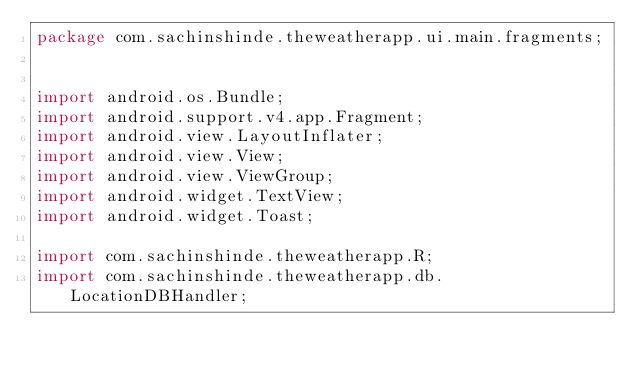<code> <loc_0><loc_0><loc_500><loc_500><_Java_>package com.sachinshinde.theweatherapp.ui.main.fragments;


import android.os.Bundle;
import android.support.v4.app.Fragment;
import android.view.LayoutInflater;
import android.view.View;
import android.view.ViewGroup;
import android.widget.TextView;
import android.widget.Toast;

import com.sachinshinde.theweatherapp.R;
import com.sachinshinde.theweatherapp.db.LocationDBHandler;</code> 